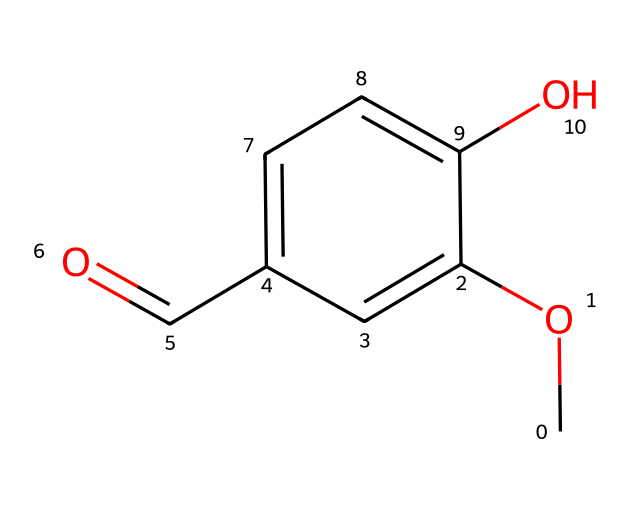What is the name of this chemical? The chemical's structure can be identified by analyzing its components. The presence of a methoxy (-OCH3) group and a hydroxyl (-OH) group, along with the aldehyde (-CHO) group, indicates that this compound is vanillin.
Answer: vanillin How many carbon atoms are present? By counting the carbon atoms in the structure, there are eight carbon atoms visible in the benzene ring, the methoxy group, and the aldehyde group.
Answer: 8 What type of functional groups are present in this molecule? The chemical has three distinct functional groups: a methoxy group (-OCH3), a hydroxyl group (-OH), and an aldehyde group (-CHO). These groups contribute to its properties.
Answer: methoxy, hydroxyl, aldehyde How many oxygen atoms can you identify in this structure? Counting the number of oxygen atoms in the molecule shows one in the methoxy group, one in the hydroxyl group, and one in the aldehyde group, totaling three oxygen atoms.
Answer: 3 What makes vanillin a phenol? Vanillin is classified as a phenol due to the presence of a hydroxyl group attached directly to an aromatic benzene ring, which is a defining characteristic of phenolic compounds.
Answer: hydroxyl group attached to an aromatic ring How does the presence of the hydroxyl group affect vanillin's properties? The hydroxyl group contributes significantly to vanillin's solubility in water and its reactivity. This group provides hydrogen bonding capabilities, enhancing interactions with polar solvents.
Answer: enhances solubility and reactivity What is the effect of the methoxy group on vanillin's aromatic character? The methoxy group is an electron-donating group that increases electron density on the aromatic ring, thereby enhancing the stability of the aromatic system and influencing its reactivity in aromatic substitution reactions.
Answer: increases electron density, enhances stability 